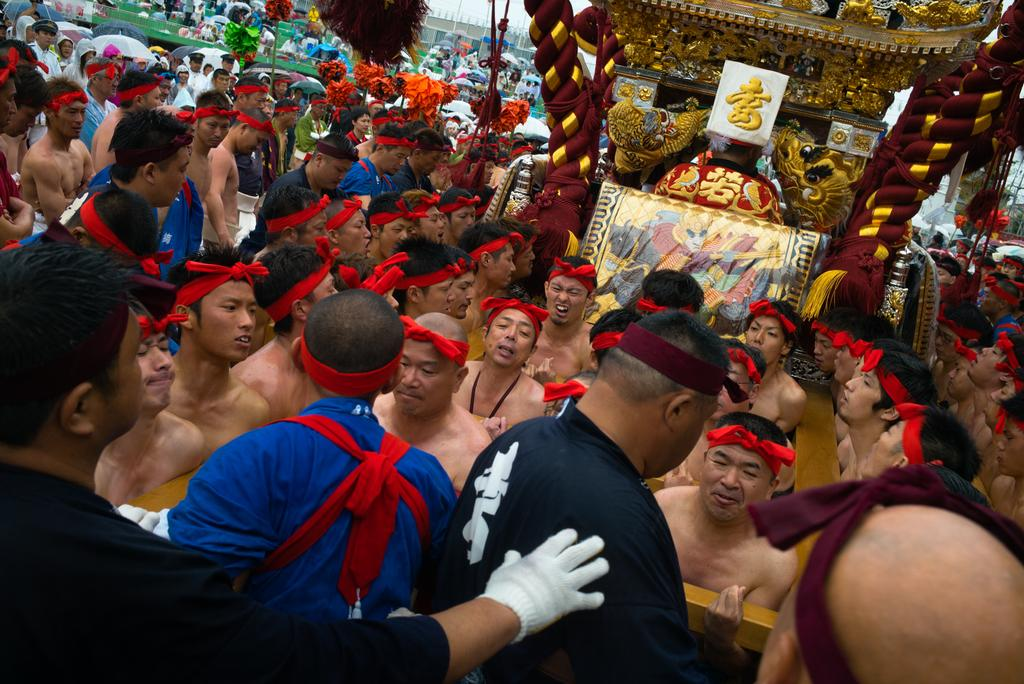Who or what is present in the image? There are people in the image. What is the color of the board in the image? There is a red board in the image. What is the color of the other object in the image? There is a silver-colored object in the image. Is there any text or writing visible in the image? Yes, there is writing on the red board or the silver-colored object. How many people are driving in the image? There is no indication of driving or vehicles in the image; it features people, a red board, and a silver-colored object. 